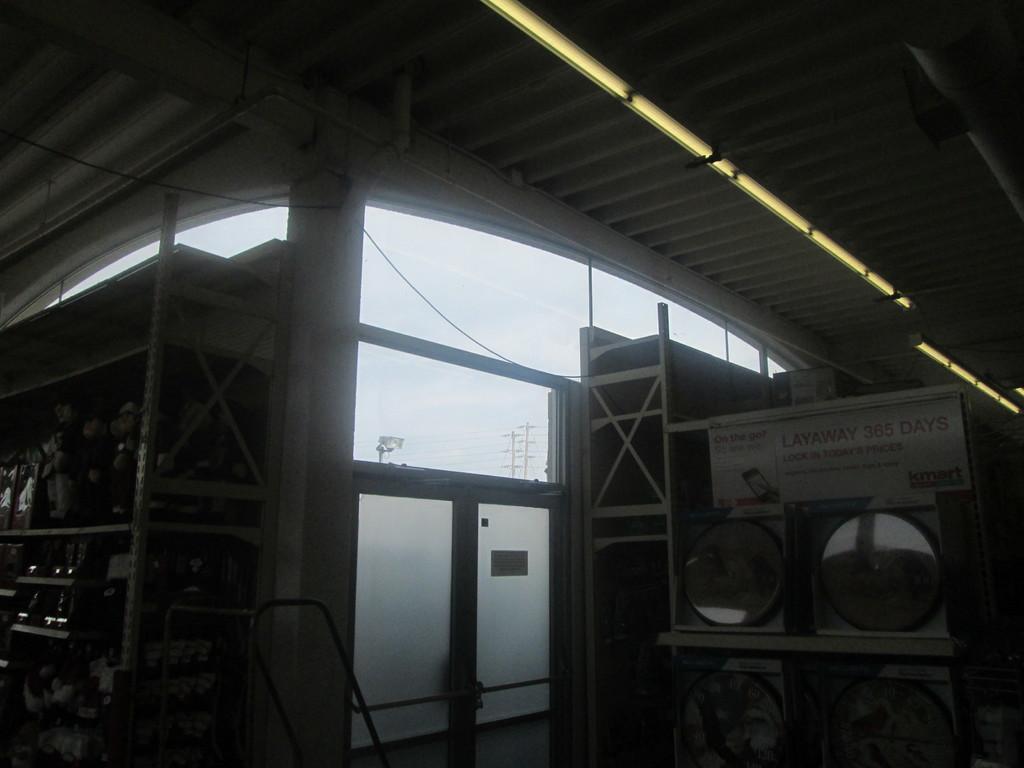Describe this image in one or two sentences. This image is taken in side of a shed where on the right, there are mirror like an objects and a rack. On the left, there are objects in the rack. On the top, there are lights to the shed. 